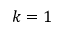<formula> <loc_0><loc_0><loc_500><loc_500>k = 1</formula> 